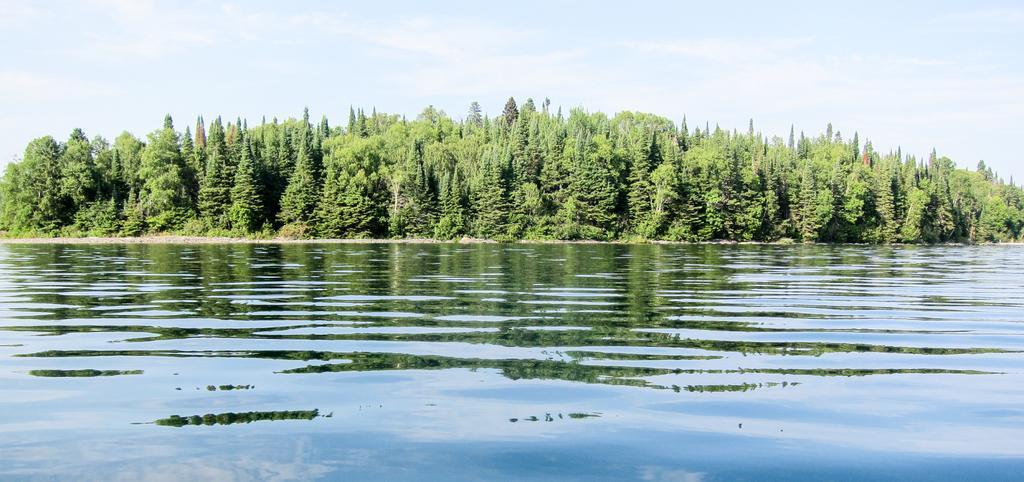Can you describe this image briefly? In this image, we can see some tree beside the lake. There is a sky at the top of the image. 